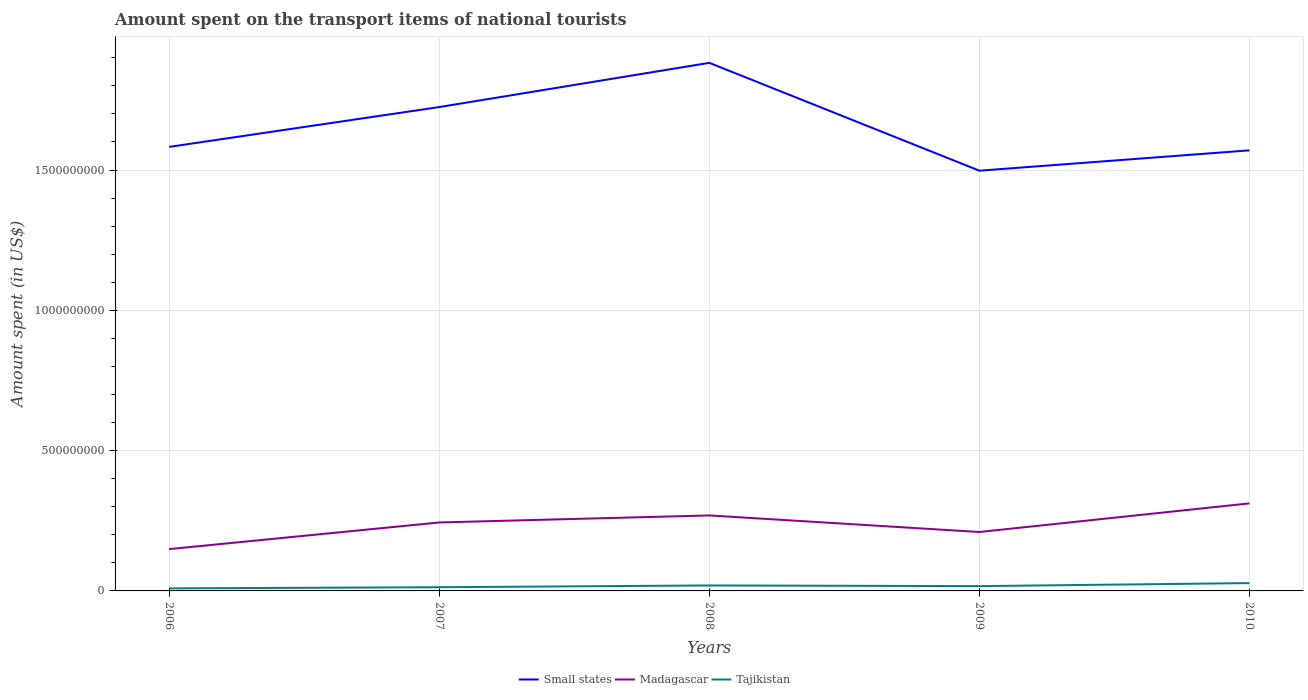How many different coloured lines are there?
Offer a very short reply. 3. Across all years, what is the maximum amount spent on the transport items of national tourists in Small states?
Your response must be concise. 1.50e+09. What is the total amount spent on the transport items of national tourists in Small states in the graph?
Your response must be concise. 8.47e+07. What is the difference between the highest and the second highest amount spent on the transport items of national tourists in Tajikistan?
Offer a very short reply. 1.88e+07. How many years are there in the graph?
Give a very brief answer. 5. What is the difference between two consecutive major ticks on the Y-axis?
Your response must be concise. 5.00e+08. Are the values on the major ticks of Y-axis written in scientific E-notation?
Offer a terse response. No. Does the graph contain any zero values?
Make the answer very short. No. What is the title of the graph?
Give a very brief answer. Amount spent on the transport items of national tourists. What is the label or title of the Y-axis?
Provide a succinct answer. Amount spent (in US$). What is the Amount spent (in US$) of Small states in 2006?
Ensure brevity in your answer.  1.58e+09. What is the Amount spent (in US$) of Madagascar in 2006?
Your response must be concise. 1.49e+08. What is the Amount spent (in US$) in Tajikistan in 2006?
Provide a short and direct response. 9.10e+06. What is the Amount spent (in US$) of Small states in 2007?
Provide a succinct answer. 1.72e+09. What is the Amount spent (in US$) in Madagascar in 2007?
Keep it short and to the point. 2.44e+08. What is the Amount spent (in US$) of Tajikistan in 2007?
Offer a very short reply. 1.32e+07. What is the Amount spent (in US$) of Small states in 2008?
Provide a short and direct response. 1.88e+09. What is the Amount spent (in US$) in Madagascar in 2008?
Your answer should be compact. 2.69e+08. What is the Amount spent (in US$) in Tajikistan in 2008?
Make the answer very short. 1.95e+07. What is the Amount spent (in US$) in Small states in 2009?
Your answer should be compact. 1.50e+09. What is the Amount spent (in US$) in Madagascar in 2009?
Provide a short and direct response. 2.10e+08. What is the Amount spent (in US$) in Tajikistan in 2009?
Offer a very short reply. 1.71e+07. What is the Amount spent (in US$) in Small states in 2010?
Your answer should be compact. 1.57e+09. What is the Amount spent (in US$) in Madagascar in 2010?
Your answer should be very brief. 3.12e+08. What is the Amount spent (in US$) of Tajikistan in 2010?
Offer a terse response. 2.79e+07. Across all years, what is the maximum Amount spent (in US$) of Small states?
Keep it short and to the point. 1.88e+09. Across all years, what is the maximum Amount spent (in US$) of Madagascar?
Ensure brevity in your answer.  3.12e+08. Across all years, what is the maximum Amount spent (in US$) in Tajikistan?
Provide a short and direct response. 2.79e+07. Across all years, what is the minimum Amount spent (in US$) in Small states?
Give a very brief answer. 1.50e+09. Across all years, what is the minimum Amount spent (in US$) in Madagascar?
Ensure brevity in your answer.  1.49e+08. Across all years, what is the minimum Amount spent (in US$) of Tajikistan?
Keep it short and to the point. 9.10e+06. What is the total Amount spent (in US$) of Small states in the graph?
Ensure brevity in your answer.  8.26e+09. What is the total Amount spent (in US$) in Madagascar in the graph?
Your answer should be very brief. 1.18e+09. What is the total Amount spent (in US$) of Tajikistan in the graph?
Ensure brevity in your answer.  8.68e+07. What is the difference between the Amount spent (in US$) in Small states in 2006 and that in 2007?
Ensure brevity in your answer.  -1.42e+08. What is the difference between the Amount spent (in US$) in Madagascar in 2006 and that in 2007?
Offer a terse response. -9.50e+07. What is the difference between the Amount spent (in US$) in Tajikistan in 2006 and that in 2007?
Make the answer very short. -4.10e+06. What is the difference between the Amount spent (in US$) of Small states in 2006 and that in 2008?
Offer a terse response. -3.00e+08. What is the difference between the Amount spent (in US$) in Madagascar in 2006 and that in 2008?
Your answer should be compact. -1.20e+08. What is the difference between the Amount spent (in US$) in Tajikistan in 2006 and that in 2008?
Make the answer very short. -1.04e+07. What is the difference between the Amount spent (in US$) in Small states in 2006 and that in 2009?
Provide a short and direct response. 8.47e+07. What is the difference between the Amount spent (in US$) of Madagascar in 2006 and that in 2009?
Provide a short and direct response. -6.10e+07. What is the difference between the Amount spent (in US$) of Tajikistan in 2006 and that in 2009?
Offer a very short reply. -8.00e+06. What is the difference between the Amount spent (in US$) of Small states in 2006 and that in 2010?
Offer a very short reply. 1.23e+07. What is the difference between the Amount spent (in US$) in Madagascar in 2006 and that in 2010?
Offer a terse response. -1.63e+08. What is the difference between the Amount spent (in US$) in Tajikistan in 2006 and that in 2010?
Keep it short and to the point. -1.88e+07. What is the difference between the Amount spent (in US$) in Small states in 2007 and that in 2008?
Provide a succinct answer. -1.58e+08. What is the difference between the Amount spent (in US$) in Madagascar in 2007 and that in 2008?
Keep it short and to the point. -2.50e+07. What is the difference between the Amount spent (in US$) in Tajikistan in 2007 and that in 2008?
Your response must be concise. -6.30e+06. What is the difference between the Amount spent (in US$) in Small states in 2007 and that in 2009?
Provide a succinct answer. 2.27e+08. What is the difference between the Amount spent (in US$) of Madagascar in 2007 and that in 2009?
Offer a very short reply. 3.40e+07. What is the difference between the Amount spent (in US$) of Tajikistan in 2007 and that in 2009?
Your response must be concise. -3.90e+06. What is the difference between the Amount spent (in US$) of Small states in 2007 and that in 2010?
Your answer should be very brief. 1.54e+08. What is the difference between the Amount spent (in US$) of Madagascar in 2007 and that in 2010?
Provide a short and direct response. -6.80e+07. What is the difference between the Amount spent (in US$) in Tajikistan in 2007 and that in 2010?
Offer a very short reply. -1.47e+07. What is the difference between the Amount spent (in US$) of Small states in 2008 and that in 2009?
Ensure brevity in your answer.  3.84e+08. What is the difference between the Amount spent (in US$) of Madagascar in 2008 and that in 2009?
Provide a short and direct response. 5.90e+07. What is the difference between the Amount spent (in US$) in Tajikistan in 2008 and that in 2009?
Keep it short and to the point. 2.40e+06. What is the difference between the Amount spent (in US$) in Small states in 2008 and that in 2010?
Make the answer very short. 3.12e+08. What is the difference between the Amount spent (in US$) in Madagascar in 2008 and that in 2010?
Offer a very short reply. -4.30e+07. What is the difference between the Amount spent (in US$) in Tajikistan in 2008 and that in 2010?
Provide a short and direct response. -8.40e+06. What is the difference between the Amount spent (in US$) in Small states in 2009 and that in 2010?
Ensure brevity in your answer.  -7.25e+07. What is the difference between the Amount spent (in US$) of Madagascar in 2009 and that in 2010?
Keep it short and to the point. -1.02e+08. What is the difference between the Amount spent (in US$) in Tajikistan in 2009 and that in 2010?
Offer a terse response. -1.08e+07. What is the difference between the Amount spent (in US$) in Small states in 2006 and the Amount spent (in US$) in Madagascar in 2007?
Provide a short and direct response. 1.34e+09. What is the difference between the Amount spent (in US$) in Small states in 2006 and the Amount spent (in US$) in Tajikistan in 2007?
Your response must be concise. 1.57e+09. What is the difference between the Amount spent (in US$) of Madagascar in 2006 and the Amount spent (in US$) of Tajikistan in 2007?
Make the answer very short. 1.36e+08. What is the difference between the Amount spent (in US$) in Small states in 2006 and the Amount spent (in US$) in Madagascar in 2008?
Keep it short and to the point. 1.31e+09. What is the difference between the Amount spent (in US$) of Small states in 2006 and the Amount spent (in US$) of Tajikistan in 2008?
Provide a short and direct response. 1.56e+09. What is the difference between the Amount spent (in US$) in Madagascar in 2006 and the Amount spent (in US$) in Tajikistan in 2008?
Make the answer very short. 1.30e+08. What is the difference between the Amount spent (in US$) in Small states in 2006 and the Amount spent (in US$) in Madagascar in 2009?
Your answer should be very brief. 1.37e+09. What is the difference between the Amount spent (in US$) of Small states in 2006 and the Amount spent (in US$) of Tajikistan in 2009?
Your response must be concise. 1.57e+09. What is the difference between the Amount spent (in US$) of Madagascar in 2006 and the Amount spent (in US$) of Tajikistan in 2009?
Your answer should be very brief. 1.32e+08. What is the difference between the Amount spent (in US$) of Small states in 2006 and the Amount spent (in US$) of Madagascar in 2010?
Your answer should be compact. 1.27e+09. What is the difference between the Amount spent (in US$) in Small states in 2006 and the Amount spent (in US$) in Tajikistan in 2010?
Give a very brief answer. 1.55e+09. What is the difference between the Amount spent (in US$) in Madagascar in 2006 and the Amount spent (in US$) in Tajikistan in 2010?
Your response must be concise. 1.21e+08. What is the difference between the Amount spent (in US$) of Small states in 2007 and the Amount spent (in US$) of Madagascar in 2008?
Give a very brief answer. 1.46e+09. What is the difference between the Amount spent (in US$) of Small states in 2007 and the Amount spent (in US$) of Tajikistan in 2008?
Offer a terse response. 1.70e+09. What is the difference between the Amount spent (in US$) in Madagascar in 2007 and the Amount spent (in US$) in Tajikistan in 2008?
Provide a short and direct response. 2.24e+08. What is the difference between the Amount spent (in US$) in Small states in 2007 and the Amount spent (in US$) in Madagascar in 2009?
Make the answer very short. 1.51e+09. What is the difference between the Amount spent (in US$) in Small states in 2007 and the Amount spent (in US$) in Tajikistan in 2009?
Offer a very short reply. 1.71e+09. What is the difference between the Amount spent (in US$) of Madagascar in 2007 and the Amount spent (in US$) of Tajikistan in 2009?
Make the answer very short. 2.27e+08. What is the difference between the Amount spent (in US$) of Small states in 2007 and the Amount spent (in US$) of Madagascar in 2010?
Your answer should be very brief. 1.41e+09. What is the difference between the Amount spent (in US$) in Small states in 2007 and the Amount spent (in US$) in Tajikistan in 2010?
Provide a succinct answer. 1.70e+09. What is the difference between the Amount spent (in US$) in Madagascar in 2007 and the Amount spent (in US$) in Tajikistan in 2010?
Provide a succinct answer. 2.16e+08. What is the difference between the Amount spent (in US$) in Small states in 2008 and the Amount spent (in US$) in Madagascar in 2009?
Provide a succinct answer. 1.67e+09. What is the difference between the Amount spent (in US$) of Small states in 2008 and the Amount spent (in US$) of Tajikistan in 2009?
Ensure brevity in your answer.  1.86e+09. What is the difference between the Amount spent (in US$) in Madagascar in 2008 and the Amount spent (in US$) in Tajikistan in 2009?
Ensure brevity in your answer.  2.52e+08. What is the difference between the Amount spent (in US$) in Small states in 2008 and the Amount spent (in US$) in Madagascar in 2010?
Provide a short and direct response. 1.57e+09. What is the difference between the Amount spent (in US$) of Small states in 2008 and the Amount spent (in US$) of Tajikistan in 2010?
Give a very brief answer. 1.85e+09. What is the difference between the Amount spent (in US$) in Madagascar in 2008 and the Amount spent (in US$) in Tajikistan in 2010?
Your answer should be compact. 2.41e+08. What is the difference between the Amount spent (in US$) in Small states in 2009 and the Amount spent (in US$) in Madagascar in 2010?
Ensure brevity in your answer.  1.19e+09. What is the difference between the Amount spent (in US$) of Small states in 2009 and the Amount spent (in US$) of Tajikistan in 2010?
Give a very brief answer. 1.47e+09. What is the difference between the Amount spent (in US$) in Madagascar in 2009 and the Amount spent (in US$) in Tajikistan in 2010?
Keep it short and to the point. 1.82e+08. What is the average Amount spent (in US$) of Small states per year?
Offer a very short reply. 1.65e+09. What is the average Amount spent (in US$) in Madagascar per year?
Your answer should be compact. 2.37e+08. What is the average Amount spent (in US$) of Tajikistan per year?
Provide a succinct answer. 1.74e+07. In the year 2006, what is the difference between the Amount spent (in US$) of Small states and Amount spent (in US$) of Madagascar?
Your response must be concise. 1.43e+09. In the year 2006, what is the difference between the Amount spent (in US$) of Small states and Amount spent (in US$) of Tajikistan?
Your response must be concise. 1.57e+09. In the year 2006, what is the difference between the Amount spent (in US$) of Madagascar and Amount spent (in US$) of Tajikistan?
Offer a terse response. 1.40e+08. In the year 2007, what is the difference between the Amount spent (in US$) of Small states and Amount spent (in US$) of Madagascar?
Offer a terse response. 1.48e+09. In the year 2007, what is the difference between the Amount spent (in US$) of Small states and Amount spent (in US$) of Tajikistan?
Your answer should be compact. 1.71e+09. In the year 2007, what is the difference between the Amount spent (in US$) in Madagascar and Amount spent (in US$) in Tajikistan?
Your answer should be very brief. 2.31e+08. In the year 2008, what is the difference between the Amount spent (in US$) of Small states and Amount spent (in US$) of Madagascar?
Make the answer very short. 1.61e+09. In the year 2008, what is the difference between the Amount spent (in US$) in Small states and Amount spent (in US$) in Tajikistan?
Keep it short and to the point. 1.86e+09. In the year 2008, what is the difference between the Amount spent (in US$) of Madagascar and Amount spent (in US$) of Tajikistan?
Your response must be concise. 2.50e+08. In the year 2009, what is the difference between the Amount spent (in US$) in Small states and Amount spent (in US$) in Madagascar?
Ensure brevity in your answer.  1.29e+09. In the year 2009, what is the difference between the Amount spent (in US$) of Small states and Amount spent (in US$) of Tajikistan?
Keep it short and to the point. 1.48e+09. In the year 2009, what is the difference between the Amount spent (in US$) in Madagascar and Amount spent (in US$) in Tajikistan?
Provide a short and direct response. 1.93e+08. In the year 2010, what is the difference between the Amount spent (in US$) of Small states and Amount spent (in US$) of Madagascar?
Make the answer very short. 1.26e+09. In the year 2010, what is the difference between the Amount spent (in US$) of Small states and Amount spent (in US$) of Tajikistan?
Give a very brief answer. 1.54e+09. In the year 2010, what is the difference between the Amount spent (in US$) of Madagascar and Amount spent (in US$) of Tajikistan?
Offer a terse response. 2.84e+08. What is the ratio of the Amount spent (in US$) of Small states in 2006 to that in 2007?
Keep it short and to the point. 0.92. What is the ratio of the Amount spent (in US$) of Madagascar in 2006 to that in 2007?
Your answer should be compact. 0.61. What is the ratio of the Amount spent (in US$) in Tajikistan in 2006 to that in 2007?
Give a very brief answer. 0.69. What is the ratio of the Amount spent (in US$) in Small states in 2006 to that in 2008?
Provide a short and direct response. 0.84. What is the ratio of the Amount spent (in US$) in Madagascar in 2006 to that in 2008?
Provide a short and direct response. 0.55. What is the ratio of the Amount spent (in US$) of Tajikistan in 2006 to that in 2008?
Provide a short and direct response. 0.47. What is the ratio of the Amount spent (in US$) of Small states in 2006 to that in 2009?
Make the answer very short. 1.06. What is the ratio of the Amount spent (in US$) of Madagascar in 2006 to that in 2009?
Provide a short and direct response. 0.71. What is the ratio of the Amount spent (in US$) of Tajikistan in 2006 to that in 2009?
Offer a terse response. 0.53. What is the ratio of the Amount spent (in US$) in Small states in 2006 to that in 2010?
Offer a terse response. 1.01. What is the ratio of the Amount spent (in US$) in Madagascar in 2006 to that in 2010?
Your response must be concise. 0.48. What is the ratio of the Amount spent (in US$) in Tajikistan in 2006 to that in 2010?
Your answer should be compact. 0.33. What is the ratio of the Amount spent (in US$) of Small states in 2007 to that in 2008?
Your answer should be compact. 0.92. What is the ratio of the Amount spent (in US$) of Madagascar in 2007 to that in 2008?
Give a very brief answer. 0.91. What is the ratio of the Amount spent (in US$) of Tajikistan in 2007 to that in 2008?
Your answer should be very brief. 0.68. What is the ratio of the Amount spent (in US$) in Small states in 2007 to that in 2009?
Provide a short and direct response. 1.15. What is the ratio of the Amount spent (in US$) of Madagascar in 2007 to that in 2009?
Offer a terse response. 1.16. What is the ratio of the Amount spent (in US$) of Tajikistan in 2007 to that in 2009?
Provide a succinct answer. 0.77. What is the ratio of the Amount spent (in US$) of Small states in 2007 to that in 2010?
Give a very brief answer. 1.1. What is the ratio of the Amount spent (in US$) of Madagascar in 2007 to that in 2010?
Your response must be concise. 0.78. What is the ratio of the Amount spent (in US$) in Tajikistan in 2007 to that in 2010?
Your answer should be very brief. 0.47. What is the ratio of the Amount spent (in US$) in Small states in 2008 to that in 2009?
Give a very brief answer. 1.26. What is the ratio of the Amount spent (in US$) in Madagascar in 2008 to that in 2009?
Offer a terse response. 1.28. What is the ratio of the Amount spent (in US$) in Tajikistan in 2008 to that in 2009?
Your answer should be very brief. 1.14. What is the ratio of the Amount spent (in US$) of Small states in 2008 to that in 2010?
Your answer should be compact. 1.2. What is the ratio of the Amount spent (in US$) of Madagascar in 2008 to that in 2010?
Provide a short and direct response. 0.86. What is the ratio of the Amount spent (in US$) of Tajikistan in 2008 to that in 2010?
Your response must be concise. 0.7. What is the ratio of the Amount spent (in US$) in Small states in 2009 to that in 2010?
Keep it short and to the point. 0.95. What is the ratio of the Amount spent (in US$) in Madagascar in 2009 to that in 2010?
Your response must be concise. 0.67. What is the ratio of the Amount spent (in US$) of Tajikistan in 2009 to that in 2010?
Offer a very short reply. 0.61. What is the difference between the highest and the second highest Amount spent (in US$) in Small states?
Make the answer very short. 1.58e+08. What is the difference between the highest and the second highest Amount spent (in US$) in Madagascar?
Your answer should be very brief. 4.30e+07. What is the difference between the highest and the second highest Amount spent (in US$) of Tajikistan?
Offer a very short reply. 8.40e+06. What is the difference between the highest and the lowest Amount spent (in US$) of Small states?
Keep it short and to the point. 3.84e+08. What is the difference between the highest and the lowest Amount spent (in US$) in Madagascar?
Provide a short and direct response. 1.63e+08. What is the difference between the highest and the lowest Amount spent (in US$) in Tajikistan?
Offer a terse response. 1.88e+07. 